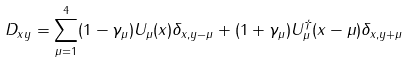Convert formula to latex. <formula><loc_0><loc_0><loc_500><loc_500>D _ { x y } = \sum _ { \mu = 1 } ^ { 4 } ( 1 - \gamma _ { \mu } ) U _ { \mu } ( x ) \delta _ { x , y - \mu } + ( 1 + \gamma _ { \mu } ) U ^ { \dagger } _ { \mu } ( x - \mu ) \delta _ { x , y + \mu }</formula> 